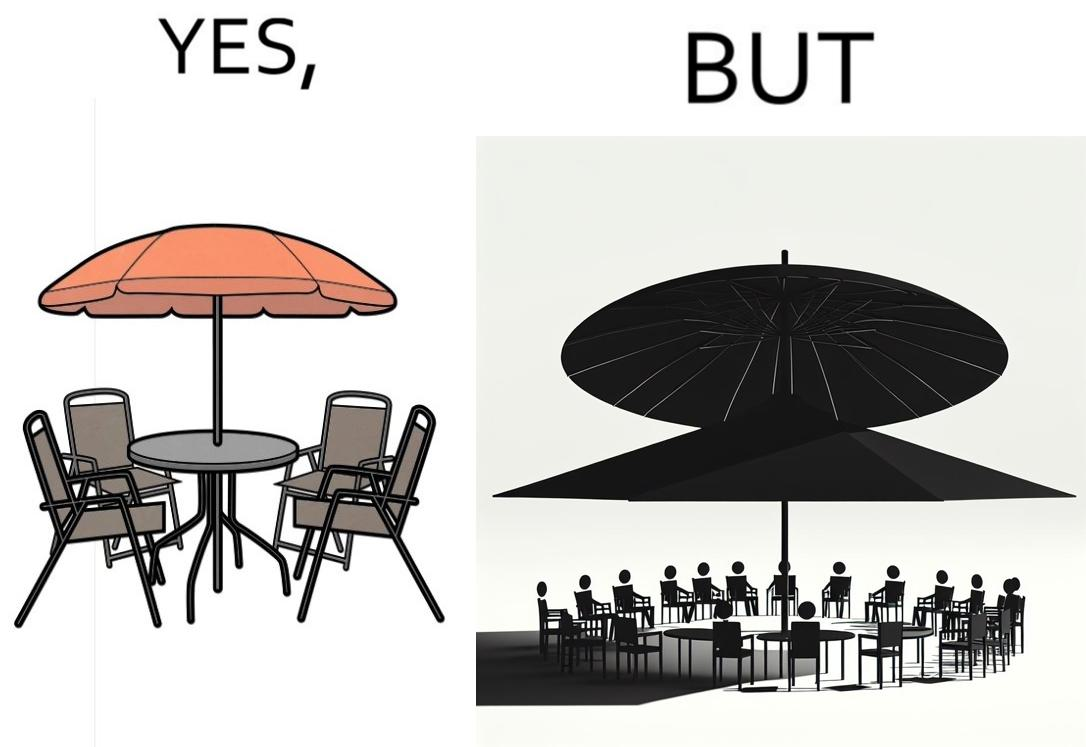Explain the humor or irony in this image. The image is ironical, as the umbrella is meant to provide shadow in the area where the chairs are present, but due to the orientation of the rays of the sun, all the chairs are in sunlight, and the umbrella is of no use in this situation. 